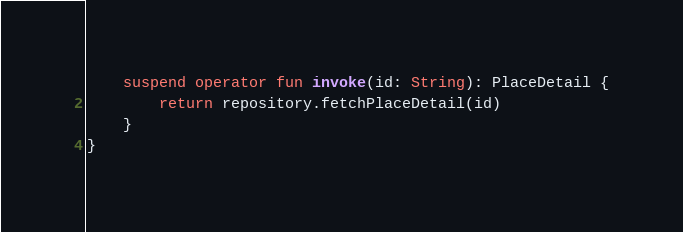<code> <loc_0><loc_0><loc_500><loc_500><_Kotlin_>    suspend operator fun invoke(id: String): PlaceDetail {
        return repository.fetchPlaceDetail(id)
    }
}</code> 